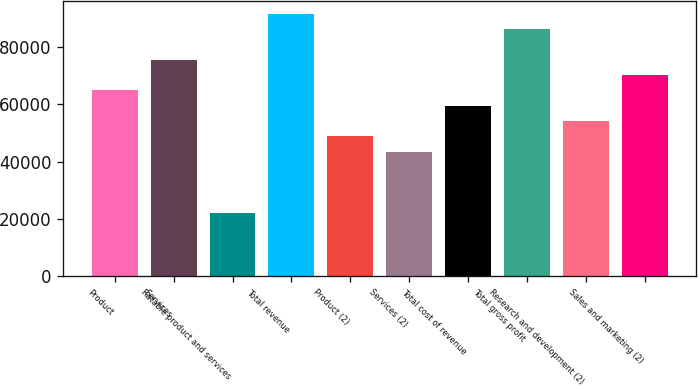Convert chart to OTSL. <chart><loc_0><loc_0><loc_500><loc_500><bar_chart><fcel>Product<fcel>Services<fcel>Ratable product and services<fcel>Total revenue<fcel>Product (2)<fcel>Services (2)<fcel>Total cost of revenue<fcel>Total gross profit<fcel>Research and development (2)<fcel>Sales and marketing (2)<nl><fcel>64934<fcel>75674<fcel>21974<fcel>91784<fcel>48824<fcel>43454<fcel>59564<fcel>86414<fcel>54194<fcel>70304<nl></chart> 